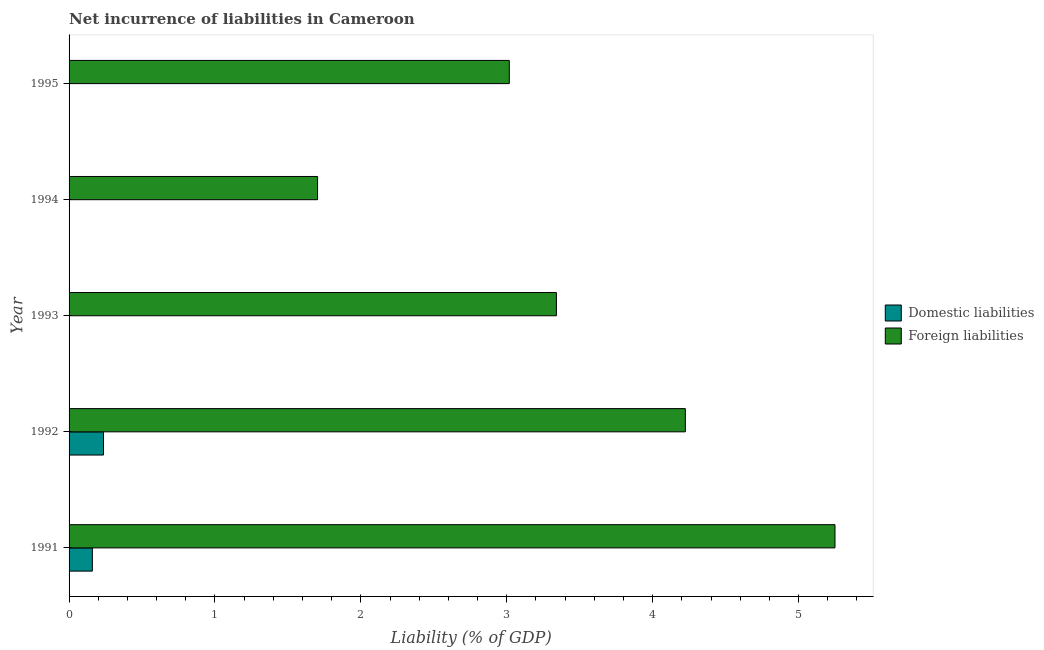Are the number of bars per tick equal to the number of legend labels?
Keep it short and to the point. No. How many bars are there on the 2nd tick from the top?
Offer a very short reply. 1. In how many cases, is the number of bars for a given year not equal to the number of legend labels?
Ensure brevity in your answer.  3. What is the incurrence of foreign liabilities in 1991?
Ensure brevity in your answer.  5.25. Across all years, what is the maximum incurrence of domestic liabilities?
Provide a succinct answer. 0.24. Across all years, what is the minimum incurrence of foreign liabilities?
Ensure brevity in your answer.  1.7. What is the total incurrence of domestic liabilities in the graph?
Your response must be concise. 0.4. What is the difference between the incurrence of domestic liabilities in 1995 and the incurrence of foreign liabilities in 1994?
Your response must be concise. -1.7. What is the average incurrence of foreign liabilities per year?
Offer a very short reply. 3.51. In the year 1991, what is the difference between the incurrence of domestic liabilities and incurrence of foreign liabilities?
Provide a succinct answer. -5.09. What is the ratio of the incurrence of domestic liabilities in 1991 to that in 1992?
Your response must be concise. 0.68. Is the incurrence of foreign liabilities in 1994 less than that in 1995?
Give a very brief answer. Yes. What is the difference between the highest and the lowest incurrence of domestic liabilities?
Your response must be concise. 0.24. In how many years, is the incurrence of foreign liabilities greater than the average incurrence of foreign liabilities taken over all years?
Provide a succinct answer. 2. What is the difference between two consecutive major ticks on the X-axis?
Your answer should be very brief. 1. Are the values on the major ticks of X-axis written in scientific E-notation?
Your response must be concise. No. Does the graph contain any zero values?
Give a very brief answer. Yes. Does the graph contain grids?
Provide a succinct answer. No. What is the title of the graph?
Make the answer very short. Net incurrence of liabilities in Cameroon. Does "Foreign liabilities" appear as one of the legend labels in the graph?
Offer a very short reply. Yes. What is the label or title of the X-axis?
Provide a succinct answer. Liability (% of GDP). What is the Liability (% of GDP) of Domestic liabilities in 1991?
Provide a short and direct response. 0.16. What is the Liability (% of GDP) in Foreign liabilities in 1991?
Ensure brevity in your answer.  5.25. What is the Liability (% of GDP) of Domestic liabilities in 1992?
Provide a succinct answer. 0.24. What is the Liability (% of GDP) in Foreign liabilities in 1992?
Make the answer very short. 4.22. What is the Liability (% of GDP) in Domestic liabilities in 1993?
Provide a succinct answer. 0. What is the Liability (% of GDP) of Foreign liabilities in 1993?
Offer a terse response. 3.34. What is the Liability (% of GDP) in Domestic liabilities in 1994?
Offer a terse response. 0. What is the Liability (% of GDP) of Foreign liabilities in 1994?
Keep it short and to the point. 1.7. What is the Liability (% of GDP) in Foreign liabilities in 1995?
Ensure brevity in your answer.  3.02. Across all years, what is the maximum Liability (% of GDP) of Domestic liabilities?
Ensure brevity in your answer.  0.24. Across all years, what is the maximum Liability (% of GDP) of Foreign liabilities?
Ensure brevity in your answer.  5.25. Across all years, what is the minimum Liability (% of GDP) of Foreign liabilities?
Offer a very short reply. 1.7. What is the total Liability (% of GDP) in Domestic liabilities in the graph?
Make the answer very short. 0.4. What is the total Liability (% of GDP) of Foreign liabilities in the graph?
Provide a succinct answer. 17.53. What is the difference between the Liability (% of GDP) of Domestic liabilities in 1991 and that in 1992?
Your answer should be compact. -0.08. What is the difference between the Liability (% of GDP) of Foreign liabilities in 1991 and that in 1992?
Your response must be concise. 1.03. What is the difference between the Liability (% of GDP) in Foreign liabilities in 1991 and that in 1993?
Offer a very short reply. 1.91. What is the difference between the Liability (% of GDP) of Foreign liabilities in 1991 and that in 1994?
Your response must be concise. 3.55. What is the difference between the Liability (% of GDP) of Foreign liabilities in 1991 and that in 1995?
Keep it short and to the point. 2.23. What is the difference between the Liability (% of GDP) of Foreign liabilities in 1992 and that in 1993?
Your response must be concise. 0.88. What is the difference between the Liability (% of GDP) in Foreign liabilities in 1992 and that in 1994?
Your answer should be compact. 2.52. What is the difference between the Liability (% of GDP) in Foreign liabilities in 1992 and that in 1995?
Your response must be concise. 1.21. What is the difference between the Liability (% of GDP) of Foreign liabilities in 1993 and that in 1994?
Provide a short and direct response. 1.64. What is the difference between the Liability (% of GDP) in Foreign liabilities in 1993 and that in 1995?
Provide a short and direct response. 0.32. What is the difference between the Liability (% of GDP) of Foreign liabilities in 1994 and that in 1995?
Provide a short and direct response. -1.31. What is the difference between the Liability (% of GDP) in Domestic liabilities in 1991 and the Liability (% of GDP) in Foreign liabilities in 1992?
Your response must be concise. -4.06. What is the difference between the Liability (% of GDP) in Domestic liabilities in 1991 and the Liability (% of GDP) in Foreign liabilities in 1993?
Keep it short and to the point. -3.18. What is the difference between the Liability (% of GDP) of Domestic liabilities in 1991 and the Liability (% of GDP) of Foreign liabilities in 1994?
Your answer should be very brief. -1.54. What is the difference between the Liability (% of GDP) in Domestic liabilities in 1991 and the Liability (% of GDP) in Foreign liabilities in 1995?
Make the answer very short. -2.86. What is the difference between the Liability (% of GDP) in Domestic liabilities in 1992 and the Liability (% of GDP) in Foreign liabilities in 1993?
Your response must be concise. -3.1. What is the difference between the Liability (% of GDP) in Domestic liabilities in 1992 and the Liability (% of GDP) in Foreign liabilities in 1994?
Offer a very short reply. -1.47. What is the difference between the Liability (% of GDP) of Domestic liabilities in 1992 and the Liability (% of GDP) of Foreign liabilities in 1995?
Your answer should be very brief. -2.78. What is the average Liability (% of GDP) in Domestic liabilities per year?
Your answer should be compact. 0.08. What is the average Liability (% of GDP) of Foreign liabilities per year?
Provide a short and direct response. 3.51. In the year 1991, what is the difference between the Liability (% of GDP) of Domestic liabilities and Liability (% of GDP) of Foreign liabilities?
Give a very brief answer. -5.09. In the year 1992, what is the difference between the Liability (% of GDP) in Domestic liabilities and Liability (% of GDP) in Foreign liabilities?
Offer a very short reply. -3.99. What is the ratio of the Liability (% of GDP) of Domestic liabilities in 1991 to that in 1992?
Your response must be concise. 0.68. What is the ratio of the Liability (% of GDP) in Foreign liabilities in 1991 to that in 1992?
Your response must be concise. 1.24. What is the ratio of the Liability (% of GDP) in Foreign liabilities in 1991 to that in 1993?
Your response must be concise. 1.57. What is the ratio of the Liability (% of GDP) in Foreign liabilities in 1991 to that in 1994?
Your answer should be compact. 3.08. What is the ratio of the Liability (% of GDP) of Foreign liabilities in 1991 to that in 1995?
Keep it short and to the point. 1.74. What is the ratio of the Liability (% of GDP) of Foreign liabilities in 1992 to that in 1993?
Give a very brief answer. 1.26. What is the ratio of the Liability (% of GDP) of Foreign liabilities in 1992 to that in 1994?
Your answer should be compact. 2.48. What is the ratio of the Liability (% of GDP) of Foreign liabilities in 1992 to that in 1995?
Provide a short and direct response. 1.4. What is the ratio of the Liability (% of GDP) of Foreign liabilities in 1993 to that in 1994?
Make the answer very short. 1.96. What is the ratio of the Liability (% of GDP) in Foreign liabilities in 1993 to that in 1995?
Keep it short and to the point. 1.11. What is the ratio of the Liability (% of GDP) in Foreign liabilities in 1994 to that in 1995?
Give a very brief answer. 0.56. What is the difference between the highest and the second highest Liability (% of GDP) in Foreign liabilities?
Give a very brief answer. 1.03. What is the difference between the highest and the lowest Liability (% of GDP) in Domestic liabilities?
Provide a succinct answer. 0.24. What is the difference between the highest and the lowest Liability (% of GDP) in Foreign liabilities?
Your answer should be compact. 3.55. 